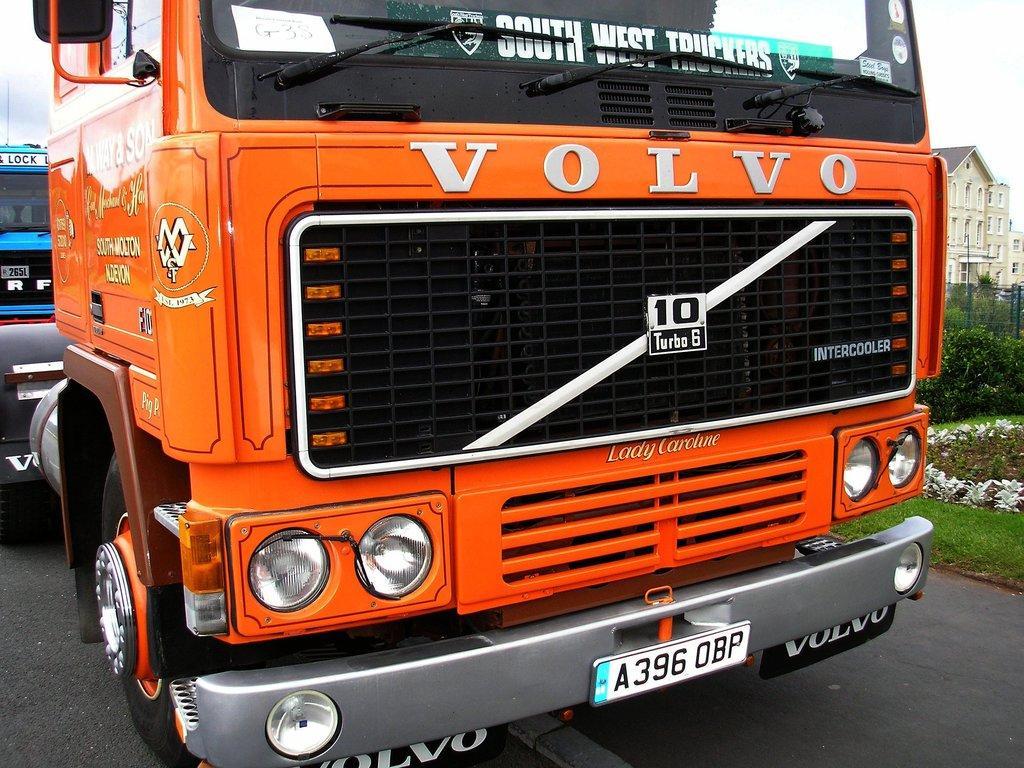Describe this image in one or two sentences. In the foreground of this image, there is a vehicle in the center of the image. Behind it, there is another vehicle. At the bottom, there is the road. In the background, there is a building, fencing, few plants, grass and the sky. 